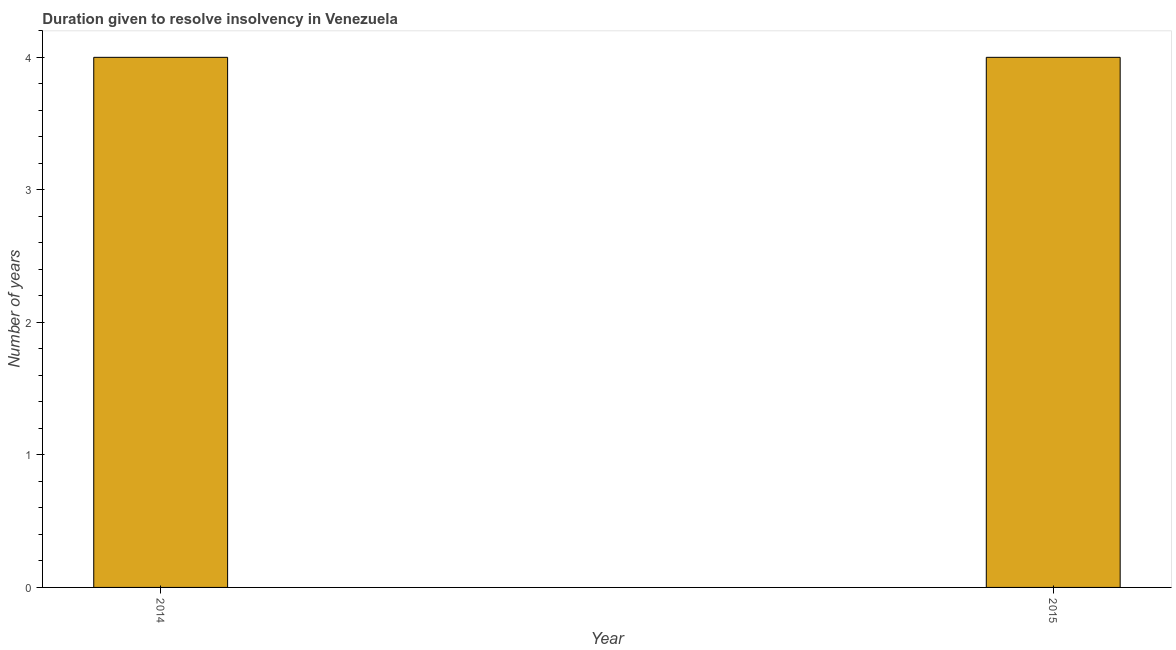Does the graph contain grids?
Your response must be concise. No. What is the title of the graph?
Give a very brief answer. Duration given to resolve insolvency in Venezuela. What is the label or title of the X-axis?
Provide a short and direct response. Year. What is the label or title of the Y-axis?
Your response must be concise. Number of years. What is the number of years to resolve insolvency in 2014?
Your answer should be compact. 4. Across all years, what is the minimum number of years to resolve insolvency?
Provide a short and direct response. 4. In which year was the number of years to resolve insolvency minimum?
Provide a succinct answer. 2014. What is the difference between the number of years to resolve insolvency in 2014 and 2015?
Give a very brief answer. 0. In how many years, is the number of years to resolve insolvency greater than the average number of years to resolve insolvency taken over all years?
Keep it short and to the point. 0. How many bars are there?
Provide a short and direct response. 2. Are all the bars in the graph horizontal?
Give a very brief answer. No. What is the difference between two consecutive major ticks on the Y-axis?
Keep it short and to the point. 1. What is the Number of years in 2014?
Ensure brevity in your answer.  4. What is the difference between the Number of years in 2014 and 2015?
Give a very brief answer. 0. What is the ratio of the Number of years in 2014 to that in 2015?
Ensure brevity in your answer.  1. 